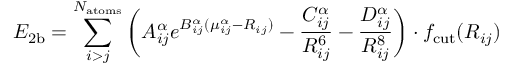Convert formula to latex. <formula><loc_0><loc_0><loc_500><loc_500>E _ { 2 b } = \sum _ { i > j } ^ { N _ { a t o m s } } \left ( A _ { i j } ^ { \alpha } e ^ { B _ { i j } ^ { \alpha } ( \mu _ { i j } ^ { \alpha } - R _ { i j } ) } - \frac { C _ { i j } ^ { \alpha } } { R _ { i j } ^ { 6 } } - \frac { D _ { i j } ^ { \alpha } } { R _ { i j } ^ { 8 } } \right ) \cdot f _ { c u t } ( R _ { i j } )</formula> 